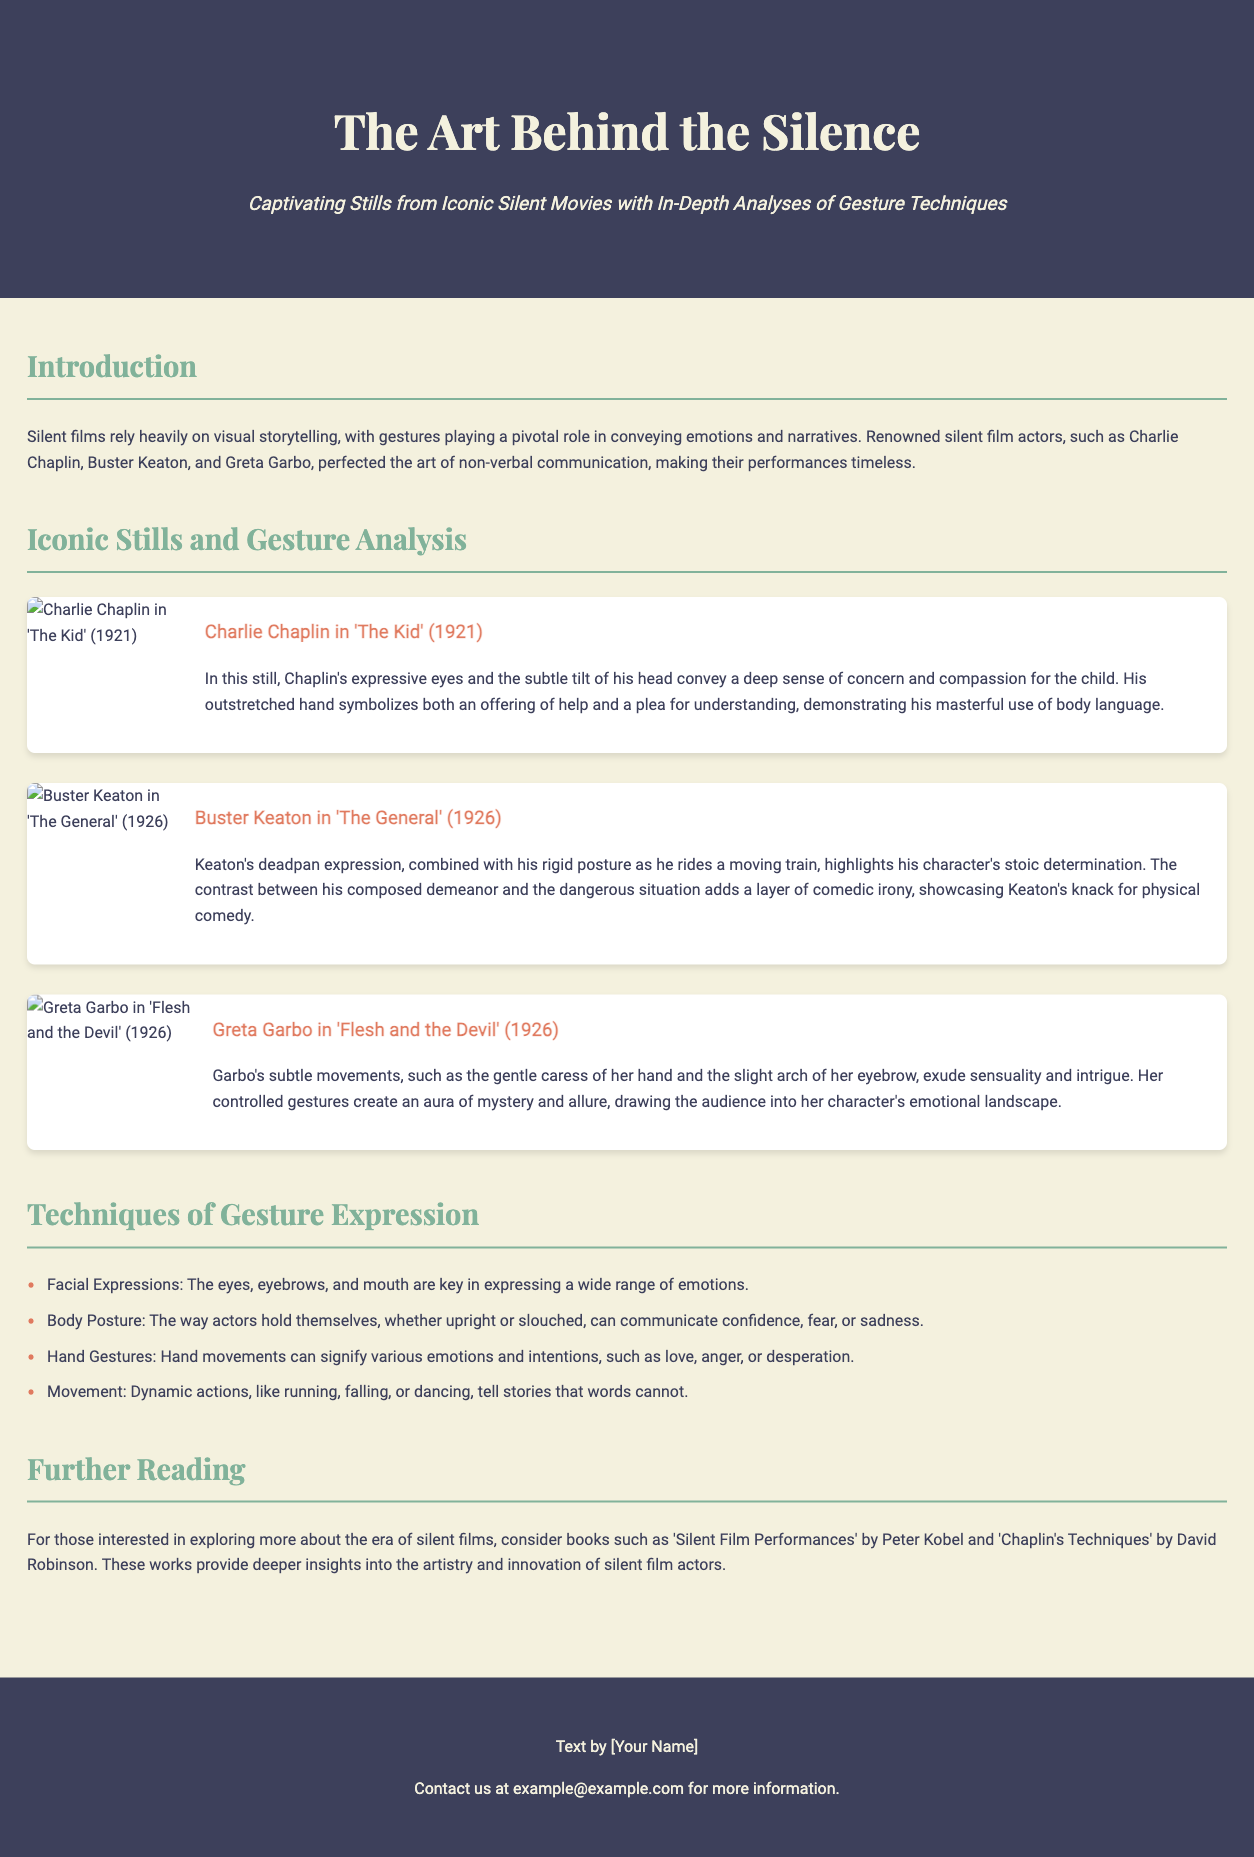What is the title of the article? The title is prominently displayed in the header of the document.
Answer: The Art Behind the Silence Who is featured in the still from 'The Kid'? The art piece description identifies the actor in the still.
Answer: Charlie Chaplin What year was 'The General' released? The release year is mentioned in the description of Buster Keaton's still.
Answer: 1926 What technique does the document mention for expressing confidence? The document lists various techniques of gesture expression, including body posture.
Answer: Body Posture Which book is suggested for further reading? The document provides a specific title for those interested in the topic.
Answer: Silent Film Performances What emotion does Greta Garbo convey in 'Flesh and the Devil'? The description of Garbo's still highlights the emotional tone conveyed.
Answer: Sensuality How many iconic stills are analyzed in the document? The number of art pieces in the section can be counted.
Answer: Three Which gesture is highlighted in the analysis of Chaplin's still? The description specifically states a gesture he performs.
Answer: Outstretched hand 